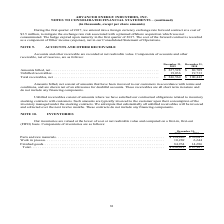According to Advanced Energy's financial document, How were Accounts and other receivable recorded by the company? at net realizable value.. The document states: "Accounts and other receivable are recorded at net realizable value. Components of accounts and other receivable, net of reserves, are as follows:..." Also, What was the amount of unbilled receivables in 2019? According to the financial document, 19,036 (in thousands). The relevant text states: ", net . $ 227,528 $ 80,709 Unbilled receivables . 19,036 19,733 Total receivables, net . $ 246,564 $ 100,442 Amounts billed, net consist of amounts that hav..." Also, What were the net amounts billed in 2018? According to the financial document, $80,709 (in thousands). The relevant text states: "r 31, 2019 2018 Amounts billed, net . $ 227,528 $ 80,709 Unbilled receivables . 19,036 19,733 Total receivables, net . $ 246,564 $ 100,442 Amounts billed, n..." Also, can you calculate: What was the change in unbilled receivables between 2018 and 2019? Based on the calculation: 19,036-19,733, the result is -697 (in thousands). This is based on the information: ", net . $ 227,528 $ 80,709 Unbilled receivables . 19,036 19,733 Total receivables, net . $ 246,564 $ 100,442 Amounts billed, net consist of amounts that hav $ 227,528 $ 80,709 Unbilled receivables . 1..." The key data points involved are: 19,036, 19,733. Also, can you calculate: What was the change in net amounts billed between 2018 and 2019? Based on the calculation: $227,528-$80,709, the result is 146819 (in thousands). This is based on the information: "1, December 31, 2019 2018 Amounts billed, net . $ 227,528 $ 80,709 Unbilled receivables . 19,036 19,733 Total receivables, net . $ 246,564 $ 100,442 Amounts r 31, 2019 2018 Amounts billed, net . $ 227..." The key data points involved are: 227,528, 80,709. Also, can you calculate: What was the percentage change in net total receivables between 2018 and 2019? To answer this question, I need to perform calculations using the financial data. The calculation is: ($246,564-$100,442)/$100,442, which equals 145.48 (percentage). This is based on the information: "vables . 19,036 19,733 Total receivables, net . $ 246,564 $ 100,442 Amounts billed, net consist of amounts that have been invoiced to our customers in accord 9,036 19,733 Total receivables, net . $ 24..." The key data points involved are: 100,442, 246,564. 